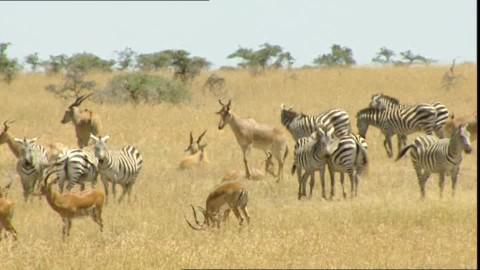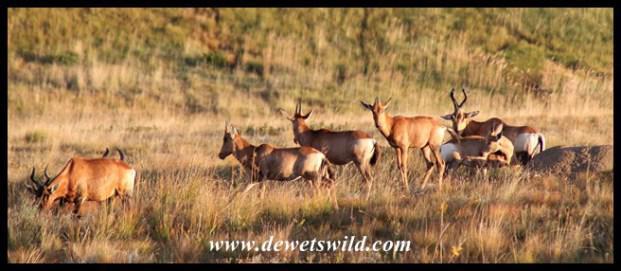The first image is the image on the left, the second image is the image on the right. Evaluate the accuracy of this statement regarding the images: "The left image shows brown antelope with another type of hooved mammal.". Is it true? Answer yes or no. Yes. 